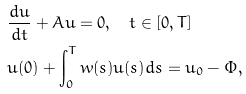Convert formula to latex. <formula><loc_0><loc_0><loc_500><loc_500>& \frac { d u } { d t } + A u = 0 , \quad t \in [ 0 , T ] \\ & u ( 0 ) + \int _ { 0 } ^ { T } w ( s ) u ( s ) d s = u _ { 0 } - \Phi ,</formula> 